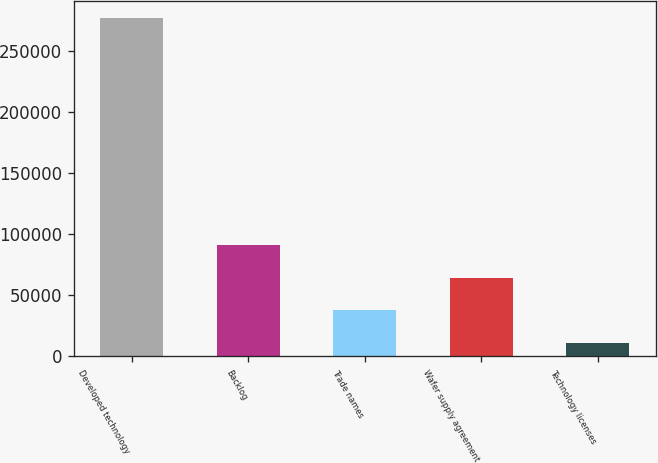Convert chart. <chart><loc_0><loc_0><loc_500><loc_500><bar_chart><fcel>Developed technology<fcel>Backlog<fcel>Trade names<fcel>Wafer supply agreement<fcel>Technology licenses<nl><fcel>277736<fcel>91035.5<fcel>37692.5<fcel>64364<fcel>11021<nl></chart> 